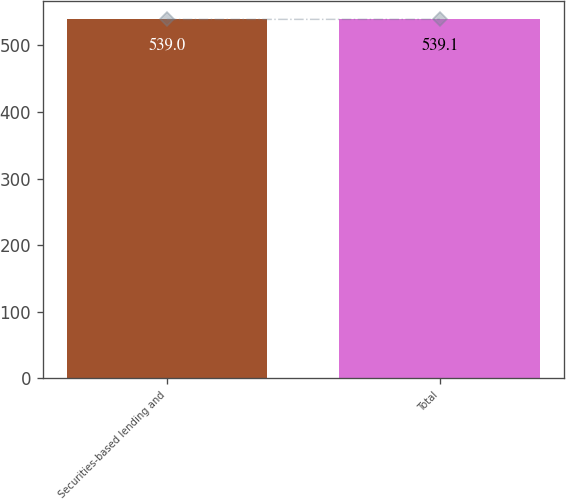<chart> <loc_0><loc_0><loc_500><loc_500><bar_chart><fcel>Securities-based lending and<fcel>Total<nl><fcel>539<fcel>539.1<nl></chart> 